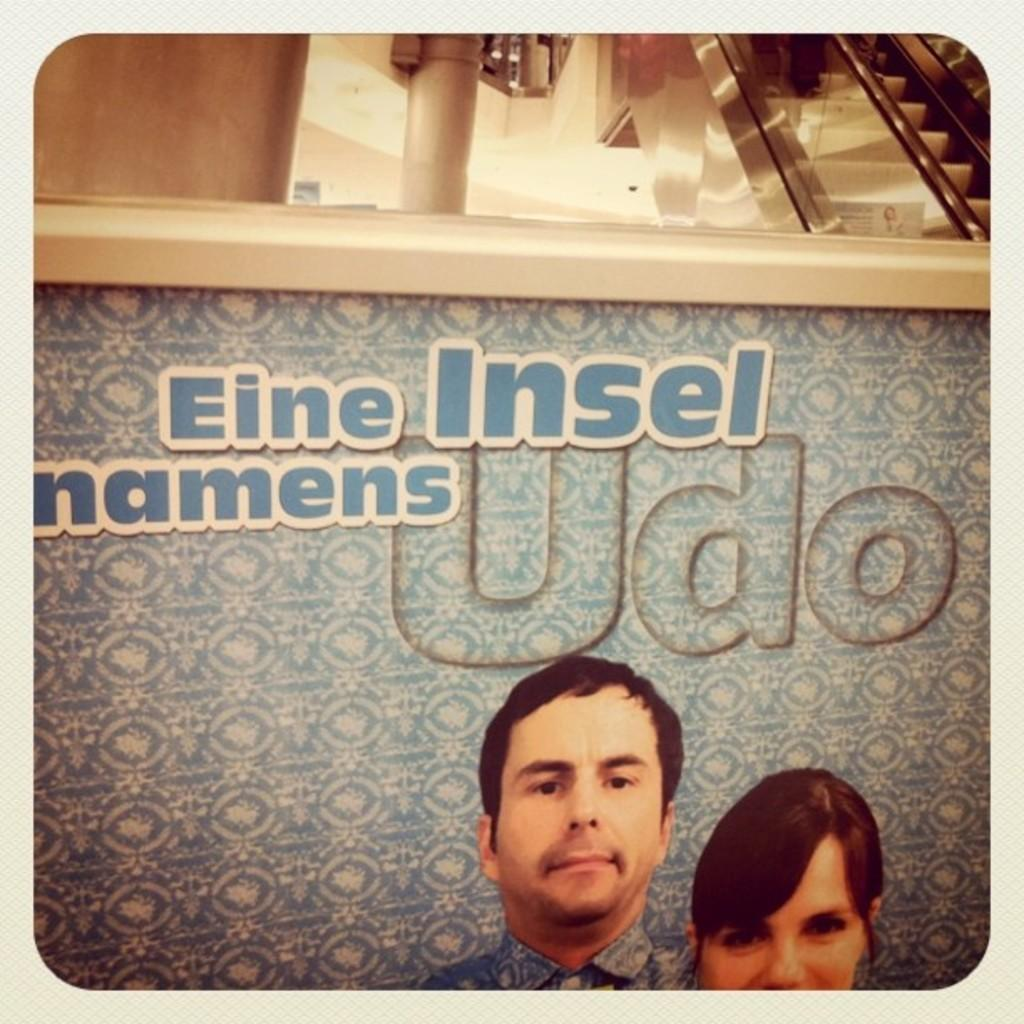What is depicted on the board in the image? There is a picture of two people on the board. What else can be seen on the board besides the picture? There is writing on the board. What architectural feature is visible in the background of the image? There is an escalator in the background. What other elements can be seen in the background of the image? There is a pillar and a wall in the background. Can you see an island in the background of the image? There is no island present in the background of the image. Is there a bed visible in the image? There is no bed present in the image. 